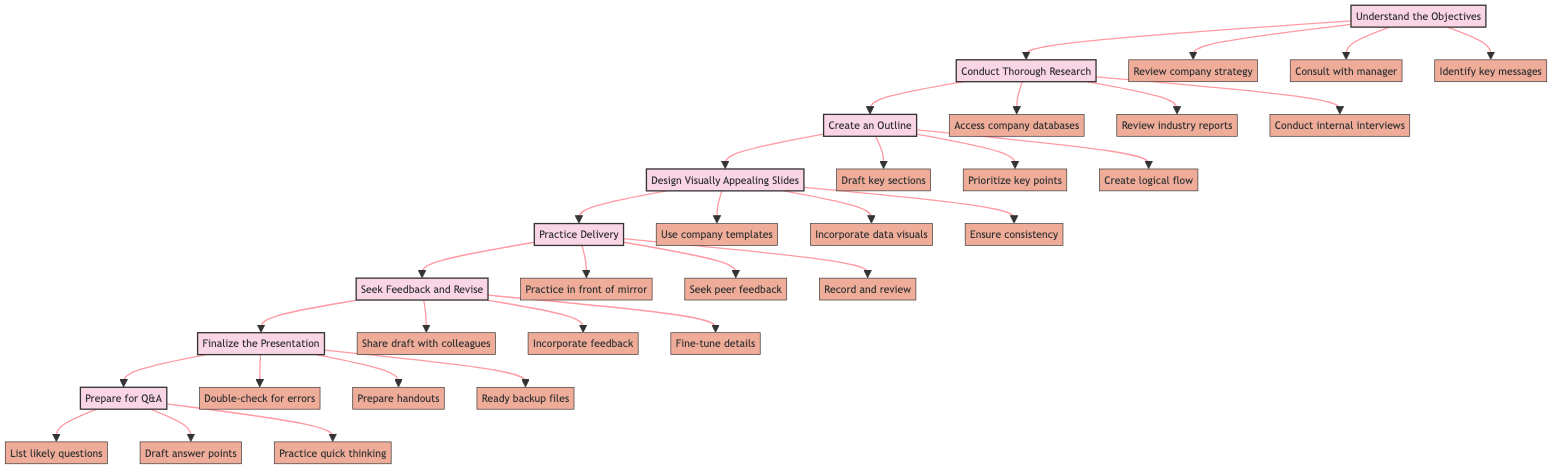What is the first step in preparing a presentation? The first step according to the diagram is "Understand the Objectives," which is indicated as the starting node.
Answer: Understand the Objectives How many action items are listed under "Finalized the Presentation"? There are three action items listed under "Finalize the Presentation." They are "Double-check for errors," "Prepare printouts or digital handouts," and "Ready backup presentation files." Counting these gives a total of three.
Answer: 3 What follows "Conduct Thorough Research"? The diagram indicates that "Create an Outline" follows "Conduct Thorough Research," which is directly connected in the flowchart.
Answer: Create an Outline What section comes before "Seek Feedback and Revise"? The section that comes before "Seek Feedback and Revise" is "Practice Delivery," which is directly linked to it in the flowchart sequence.
Answer: Practice Delivery Which step includes the action item "Draft answer points"? The action item "Draft answer points" is included under the final step "Prepare for Q&A," as indicated by its connection in the flowchart.
Answer: Prepare for Q&A How many total steps are involved in this presentation preparation process? The diagram has eight total steps identified, each denoted as a node that collectively illustrates the entire process of preparing a presentation for senior management.
Answer: 8 What is the last step in the flowchart? The last step in the flowchart is "Prepare for Q&A," which is indicated as the concluding node in the instructional flow.
Answer: Prepare for Q&A What is one of the action items under "Design Visually Appealing Slides"? One of the action items listed under "Design Visually Appealing Slides" is "Incorporate data visualizations," as depicted in the diagram.
Answer: Incorporate data visualizations What step correlates with the action item "Consult with your manager"? The action item "Consult with your manager" correlates with the step "Understand the Objectives," which is where it is categorized in the flowchart.
Answer: Understand the Objectives 